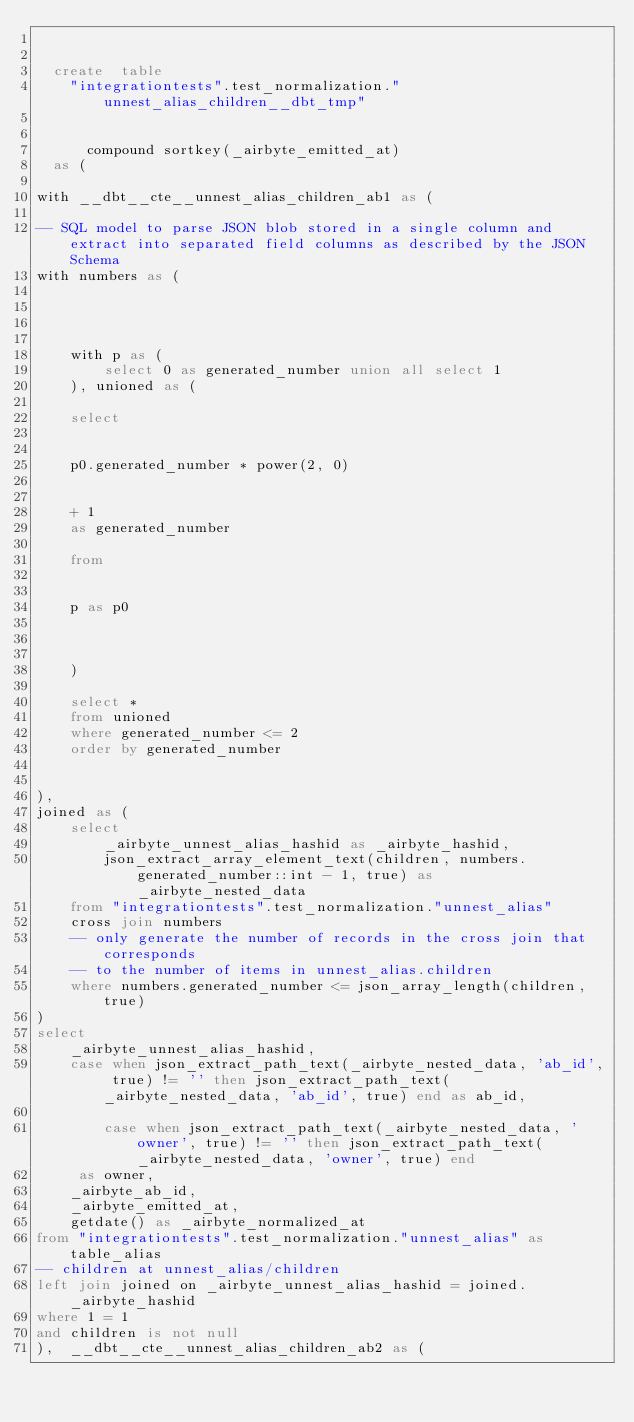Convert code to text. <code><loc_0><loc_0><loc_500><loc_500><_SQL_>

  create  table
    "integrationtests".test_normalization."unnest_alias_children__dbt_tmp"
    
    
      compound sortkey(_airbyte_emitted_at)
  as (
    
with __dbt__cte__unnest_alias_children_ab1 as (

-- SQL model to parse JSON blob stored in a single column and extract into separated field columns as described by the JSON Schema
with numbers as (
    

    

    with p as (
        select 0 as generated_number union all select 1
    ), unioned as (

    select

    
    p0.generated_number * power(2, 0)
    
    
    + 1
    as generated_number

    from

    
    p as p0
    
    

    )

    select *
    from unioned
    where generated_number <= 2
    order by generated_number


),
joined as (
    select
        _airbyte_unnest_alias_hashid as _airbyte_hashid,
        json_extract_array_element_text(children, numbers.generated_number::int - 1, true) as _airbyte_nested_data
    from "integrationtests".test_normalization."unnest_alias"
    cross join numbers
    -- only generate the number of records in the cross join that corresponds
    -- to the number of items in unnest_alias.children
    where numbers.generated_number <= json_array_length(children, true)
)
select
    _airbyte_unnest_alias_hashid,
    case when json_extract_path_text(_airbyte_nested_data, 'ab_id', true) != '' then json_extract_path_text(_airbyte_nested_data, 'ab_id', true) end as ab_id,
    
        case when json_extract_path_text(_airbyte_nested_data, 'owner', true) != '' then json_extract_path_text(_airbyte_nested_data, 'owner', true) end
     as owner,
    _airbyte_ab_id,
    _airbyte_emitted_at,
    getdate() as _airbyte_normalized_at
from "integrationtests".test_normalization."unnest_alias" as table_alias
-- children at unnest_alias/children
left join joined on _airbyte_unnest_alias_hashid = joined._airbyte_hashid
where 1 = 1
and children is not null
),  __dbt__cte__unnest_alias_children_ab2 as (
</code> 